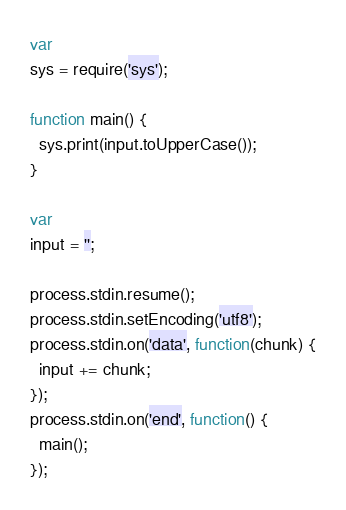Convert code to text. <code><loc_0><loc_0><loc_500><loc_500><_JavaScript_>var
sys = require('sys');

function main() {
  sys.print(input.toUpperCase());
}

var
input = '';

process.stdin.resume();
process.stdin.setEncoding('utf8');
process.stdin.on('data', function(chunk) {
  input += chunk;
});
process.stdin.on('end', function() {
  main();
});</code> 